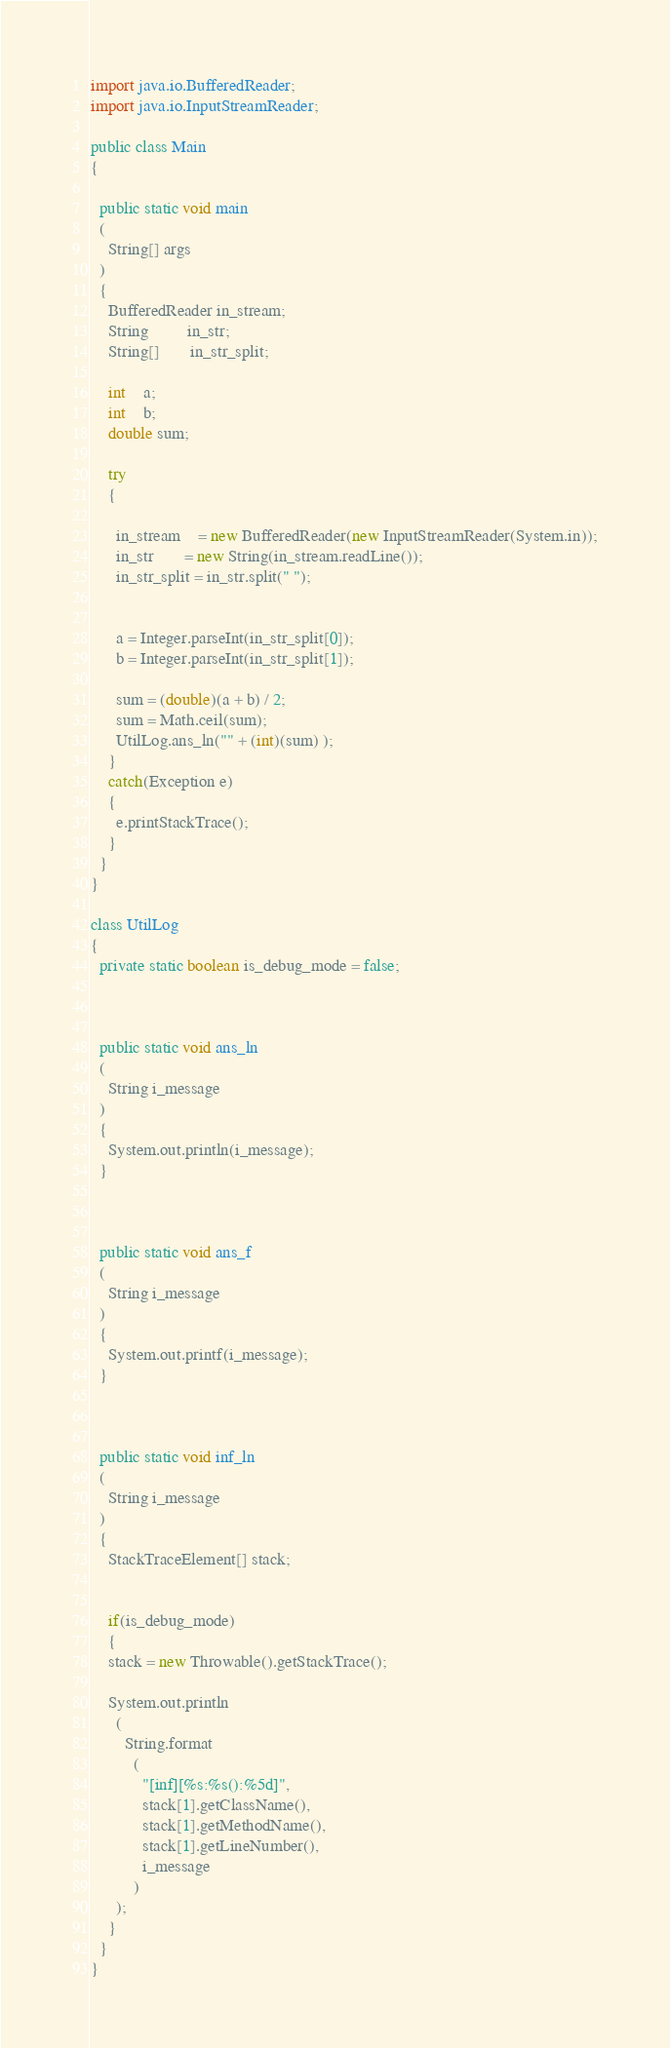<code> <loc_0><loc_0><loc_500><loc_500><_Java_>import java.io.BufferedReader;
import java.io.InputStreamReader;

public class Main
{

  public static void main
  (
    String[] args
  )
  {
    BufferedReader in_stream;
    String         in_str;
    String[]       in_str_split;

    int    a;
    int    b;
    double sum;

    try
    {

      in_stream    = new BufferedReader(new InputStreamReader(System.in));
      in_str       = new String(in_stream.readLine());
      in_str_split = in_str.split(" ");


      a = Integer.parseInt(in_str_split[0]);
      b = Integer.parseInt(in_str_split[1]);

      sum = (double)(a + b) / 2;
      sum = Math.ceil(sum);
      UtilLog.ans_ln("" + (int)(sum) );
    }
    catch(Exception e)
    {
      e.printStackTrace();
    }
  }
}

class UtilLog
{
  private static boolean is_debug_mode = false;



  public static void ans_ln
  (
    String i_message
  )
  {
    System.out.println(i_message);
  }



  public static void ans_f
  (
    String i_message
  )
  {
    System.out.printf(i_message);
  }



  public static void inf_ln
  (
    String i_message
  )
  {
    StackTraceElement[] stack;


    if(is_debug_mode)
    {
    stack = new Throwable().getStackTrace();

    System.out.println
      (
        String.format
          (
            "[inf][%s:%s():%5d]",
            stack[1].getClassName(),
            stack[1].getMethodName(),
            stack[1].getLineNumber(),
            i_message
          )
      );
    }
  }
}
</code> 